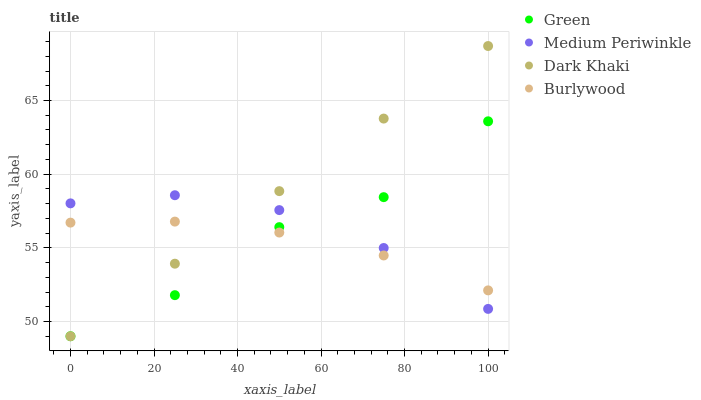Does Burlywood have the minimum area under the curve?
Answer yes or no. Yes. Does Dark Khaki have the maximum area under the curve?
Answer yes or no. Yes. Does Medium Periwinkle have the minimum area under the curve?
Answer yes or no. No. Does Medium Periwinkle have the maximum area under the curve?
Answer yes or no. No. Is Dark Khaki the smoothest?
Answer yes or no. Yes. Is Green the roughest?
Answer yes or no. Yes. Is Medium Periwinkle the smoothest?
Answer yes or no. No. Is Medium Periwinkle the roughest?
Answer yes or no. No. Does Dark Khaki have the lowest value?
Answer yes or no. Yes. Does Medium Periwinkle have the lowest value?
Answer yes or no. No. Does Dark Khaki have the highest value?
Answer yes or no. Yes. Does Medium Periwinkle have the highest value?
Answer yes or no. No. Does Dark Khaki intersect Green?
Answer yes or no. Yes. Is Dark Khaki less than Green?
Answer yes or no. No. Is Dark Khaki greater than Green?
Answer yes or no. No. 